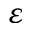Convert formula to latex. <formula><loc_0><loc_0><loc_500><loc_500>\varepsilon</formula> 